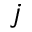Convert formula to latex. <formula><loc_0><loc_0><loc_500><loc_500>j</formula> 